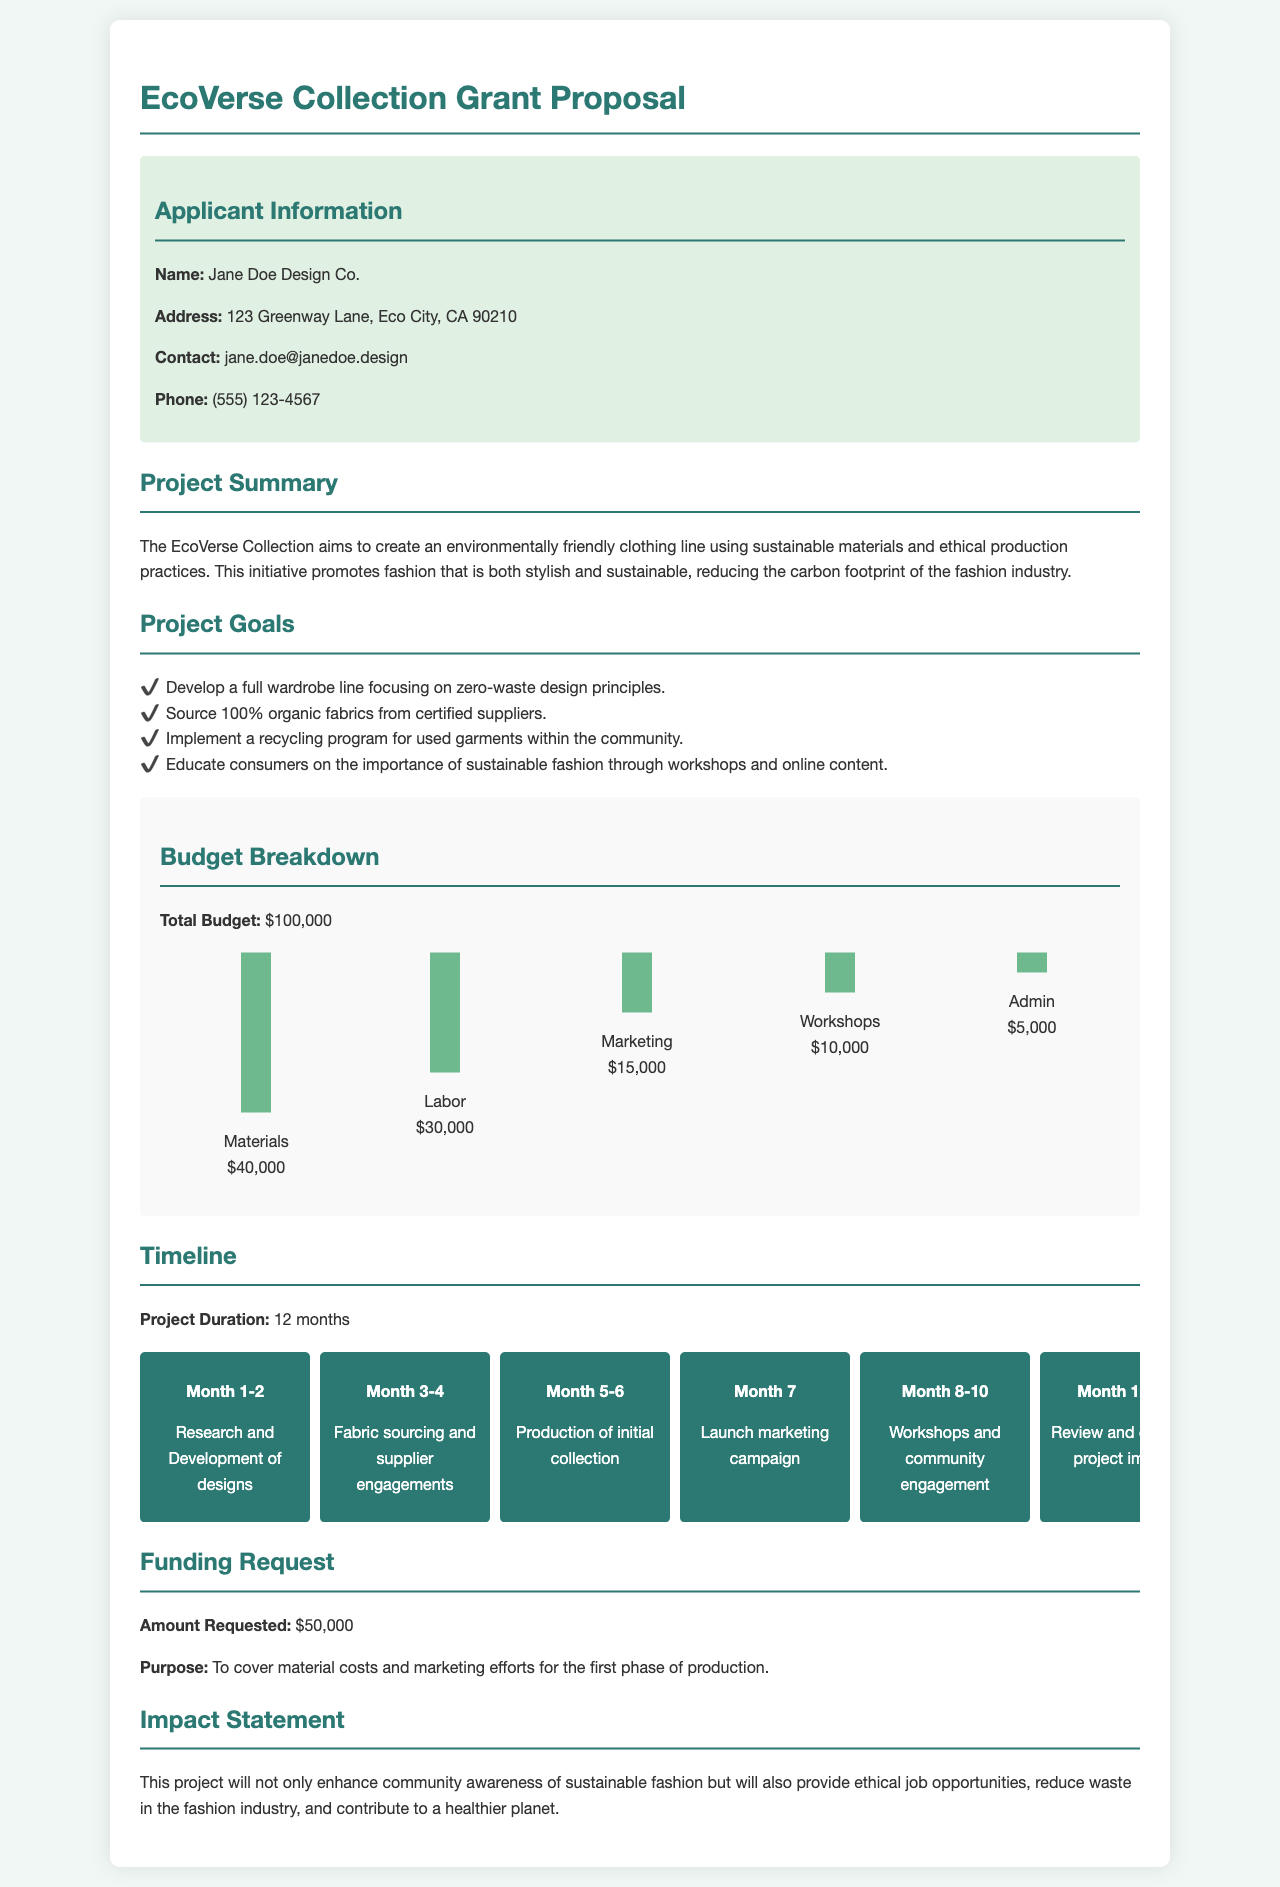what is the total budget? The total budget is explicitly stated in the document as $100,000.
Answer: $100,000 who is the applicant? The applicant's name is mentioned in the document as Jane Doe Design Co.
Answer: Jane Doe Design Co what is the amount requested? The document specifies that the amount requested is $50,000.
Answer: $50,000 what is the purpose of the funding request? The purpose is detailed in the document as to cover material costs and marketing efforts for the first phase of production.
Answer: To cover material costs and marketing efforts how many project goals are listed? The document includes a list of project goals, totaling four distinct goals.
Answer: Four which month is designated for the marketing campaign launch? The timeline details that the marketing campaign launch is scheduled for Month 7.
Answer: Month 7 what type of fabrics will be sourced? The project summary states that the initiative aims to source 100% organic fabrics.
Answer: 100% organic fabrics what percentage of the budget is allocated to materials? The budget breakdown shows that $40,000 is allocated to materials out of a total of $100,000, which is 40%.
Answer: 40% what is the anticipated duration of the project? The document mentions that the project duration is set for 12 months.
Answer: 12 months 